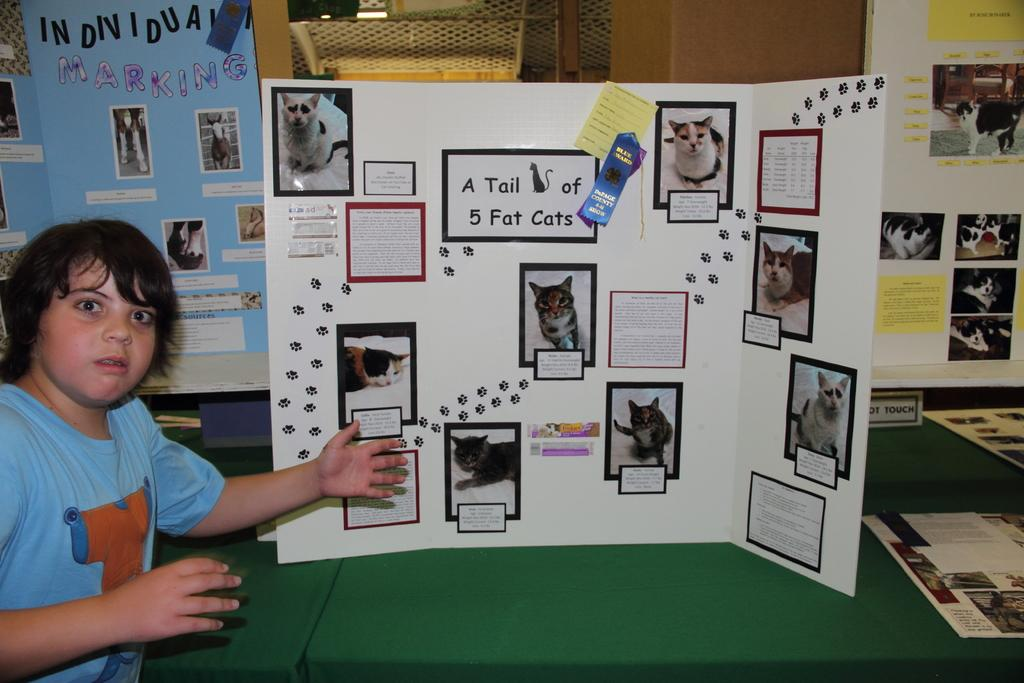<image>
Give a short and clear explanation of the subsequent image. Science Project on a posterboard that says A Tail Cat of 5 Fat Cats. 